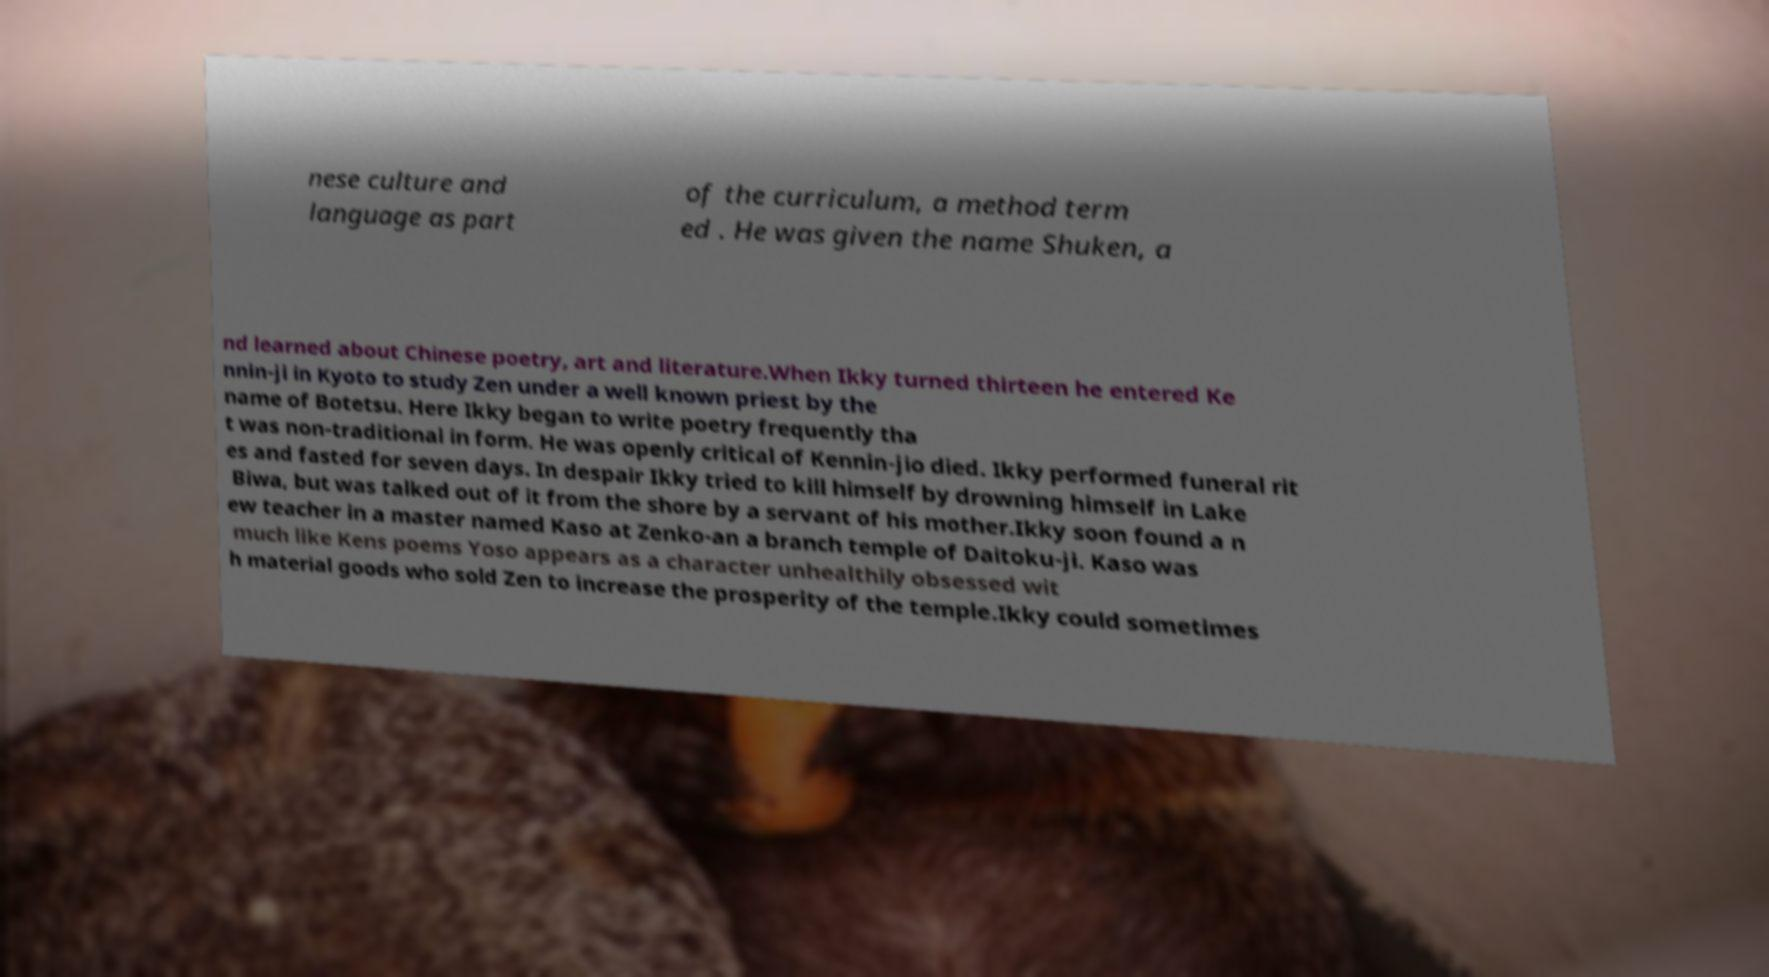Could you assist in decoding the text presented in this image and type it out clearly? nese culture and language as part of the curriculum, a method term ed . He was given the name Shuken, a nd learned about Chinese poetry, art and literature.When Ikky turned thirteen he entered Ke nnin-ji in Kyoto to study Zen under a well known priest by the name of Botetsu. Here Ikky began to write poetry frequently tha t was non-traditional in form. He was openly critical of Kennin-jio died. Ikky performed funeral rit es and fasted for seven days. In despair Ikky tried to kill himself by drowning himself in Lake Biwa, but was talked out of it from the shore by a servant of his mother.Ikky soon found a n ew teacher in a master named Kaso at Zenko-an a branch temple of Daitoku-ji. Kaso was much like Kens poems Yoso appears as a character unhealthily obsessed wit h material goods who sold Zen to increase the prosperity of the temple.Ikky could sometimes 